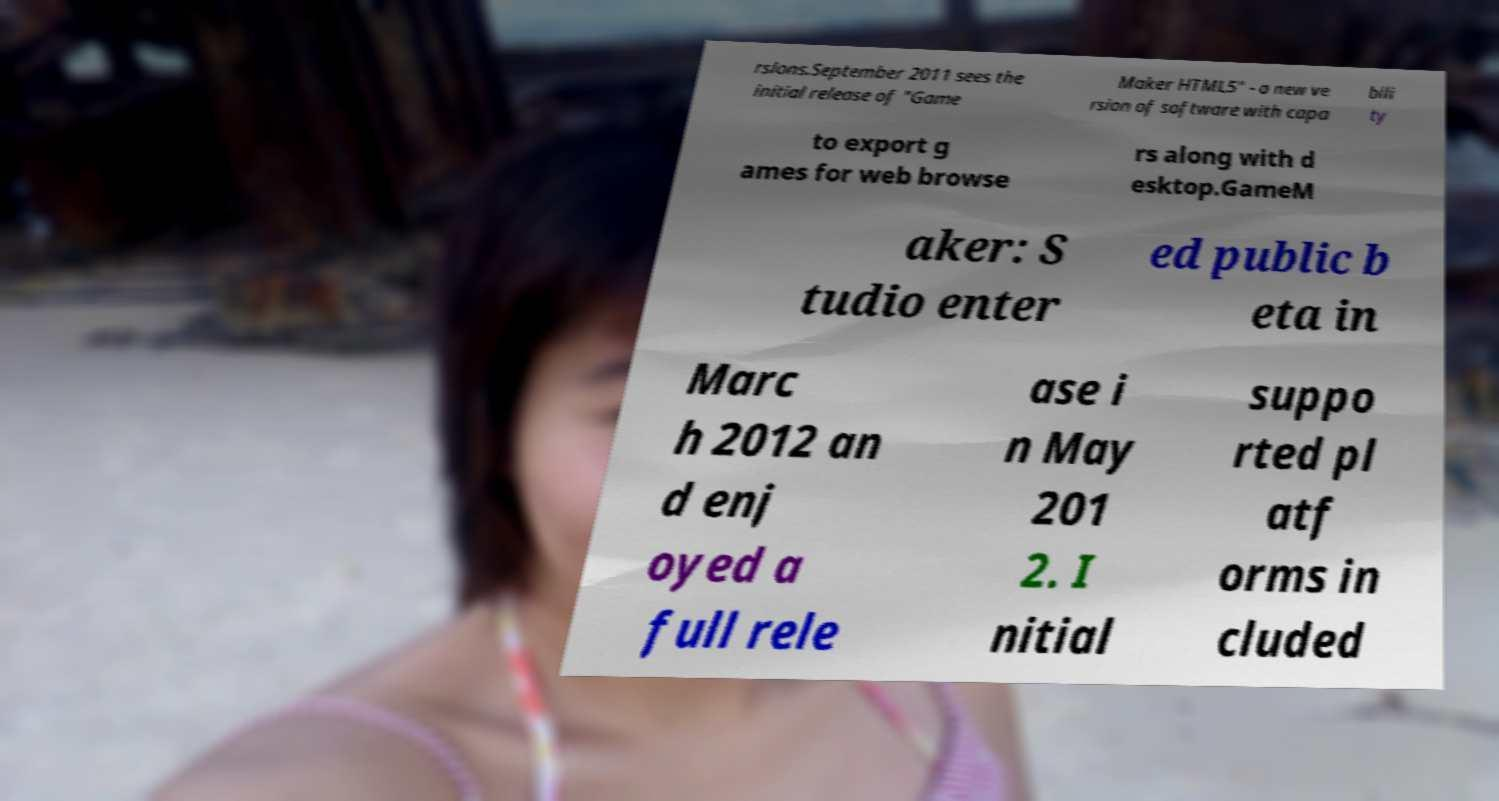I need the written content from this picture converted into text. Can you do that? rsions.September 2011 sees the initial release of "Game Maker HTML5" - a new ve rsion of software with capa bili ty to export g ames for web browse rs along with d esktop.GameM aker: S tudio enter ed public b eta in Marc h 2012 an d enj oyed a full rele ase i n May 201 2. I nitial suppo rted pl atf orms in cluded 